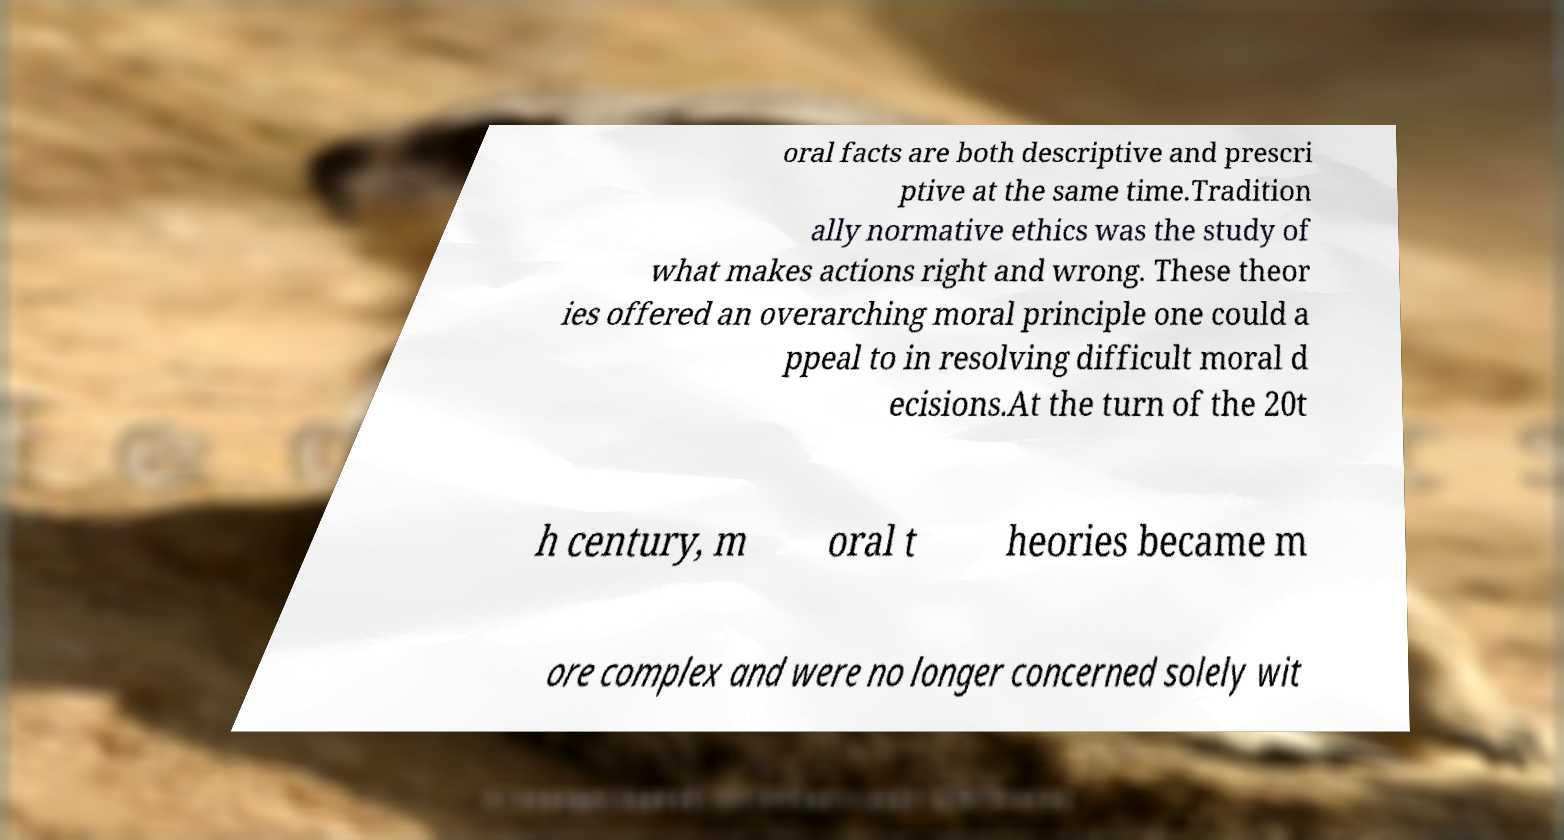Can you accurately transcribe the text from the provided image for me? oral facts are both descriptive and prescri ptive at the same time.Tradition ally normative ethics was the study of what makes actions right and wrong. These theor ies offered an overarching moral principle one could a ppeal to in resolving difficult moral d ecisions.At the turn of the 20t h century, m oral t heories became m ore complex and were no longer concerned solely wit 